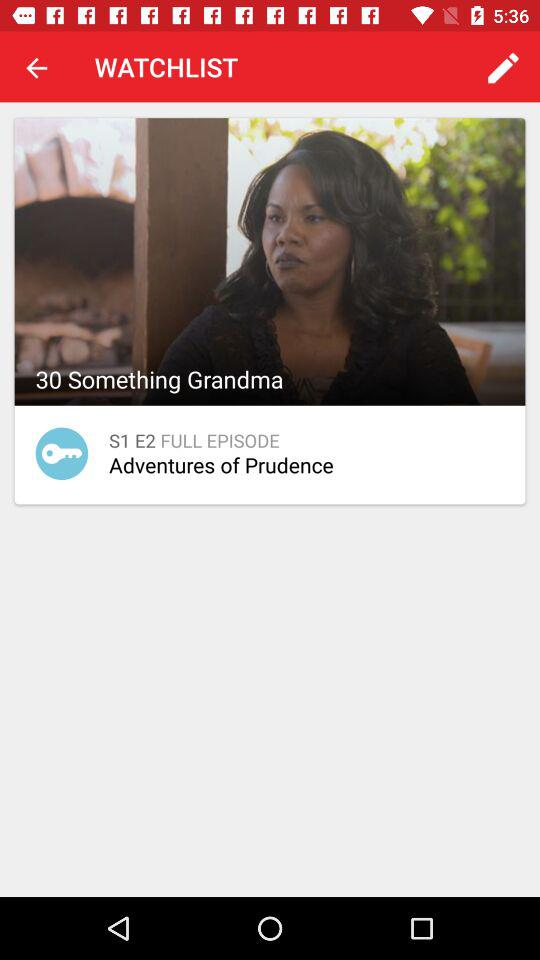What is the season number? The season number is 1. 